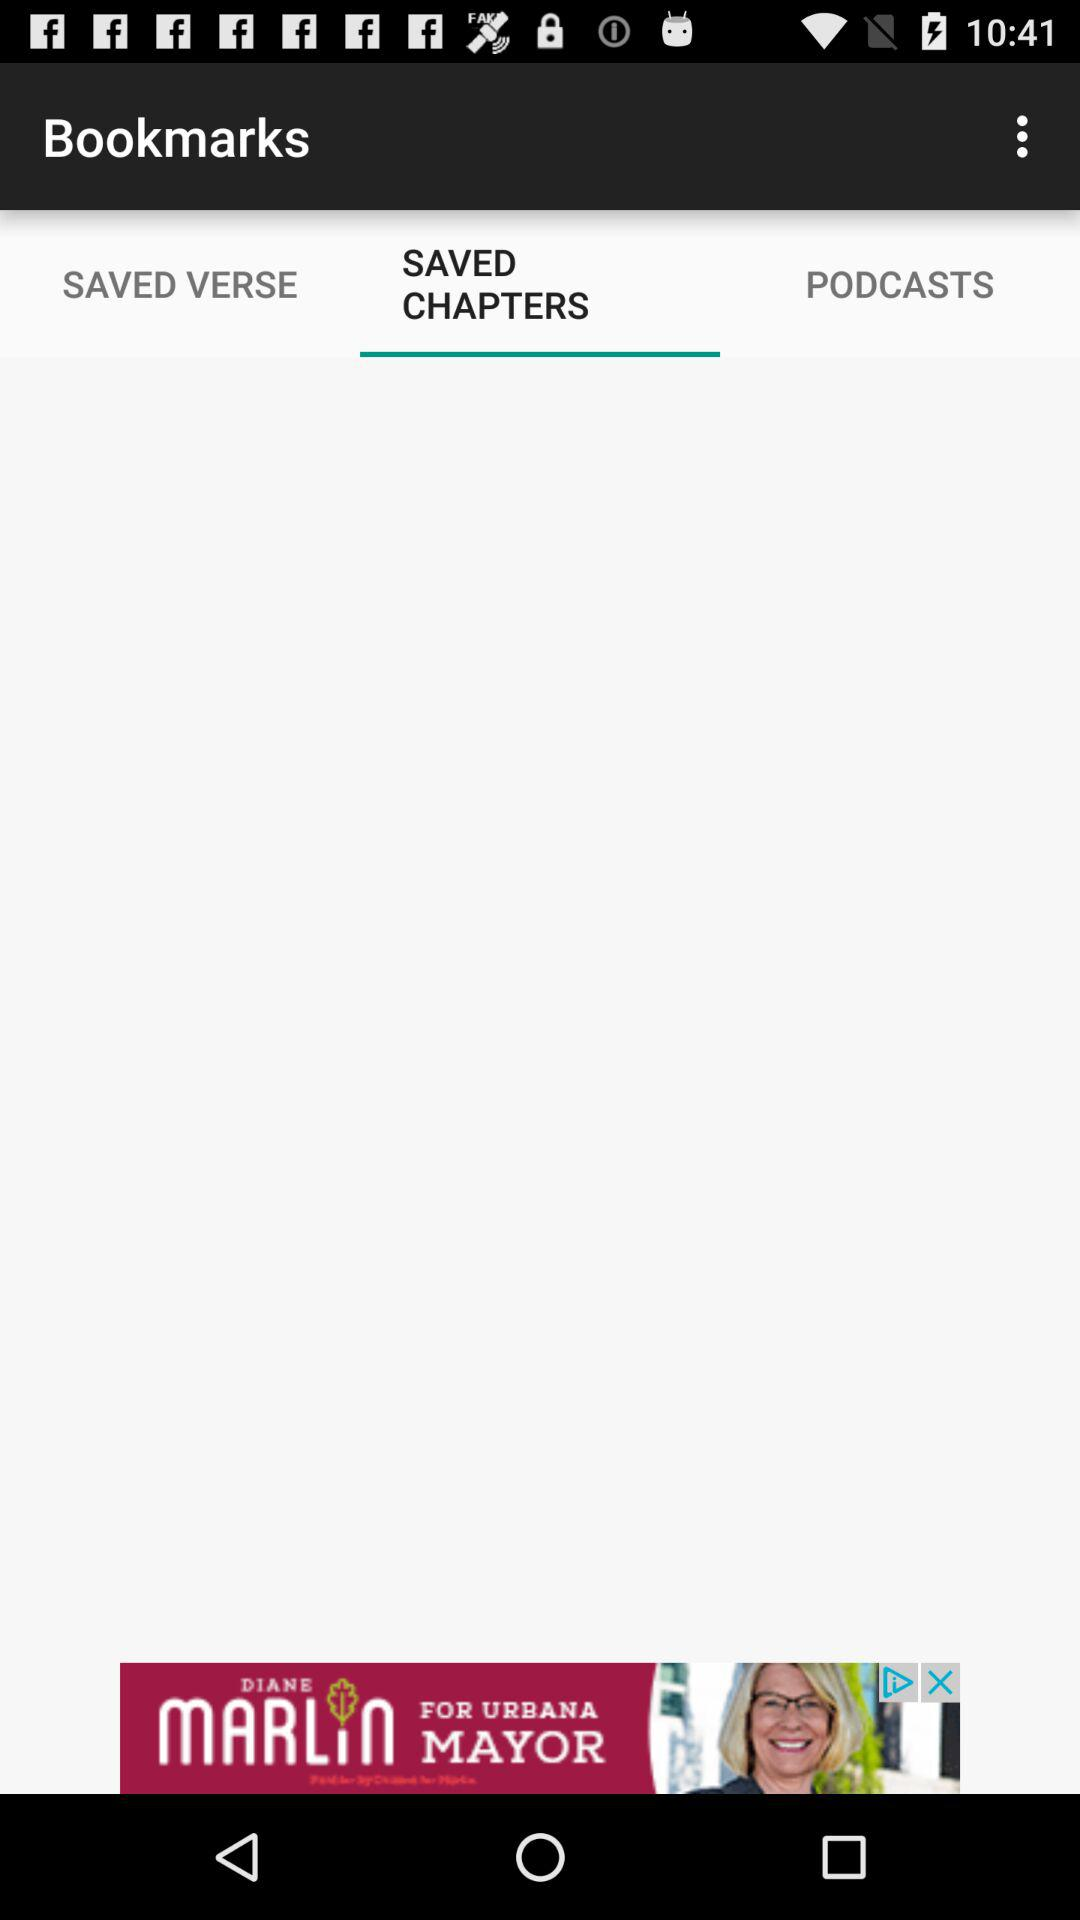Which tab has been selected? The tab that has been selected is "SAVED CHAPTERS". 